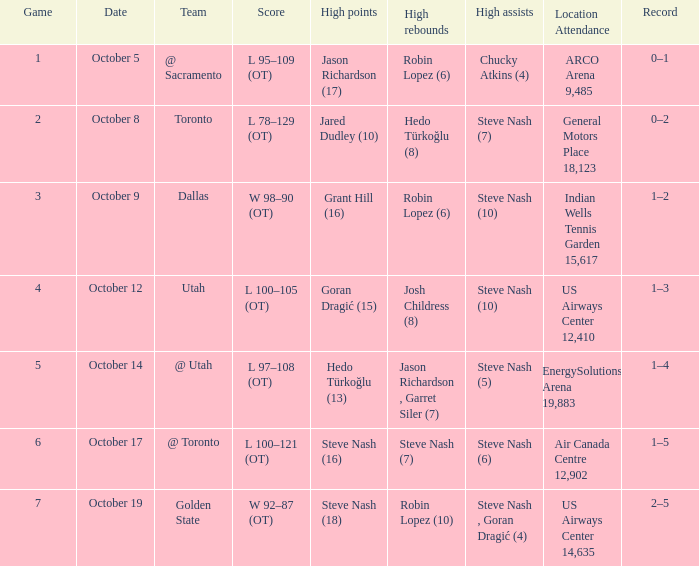On october 14, who were the two players with the top rebound counts? Jason Richardson , Garret Siler (7). 